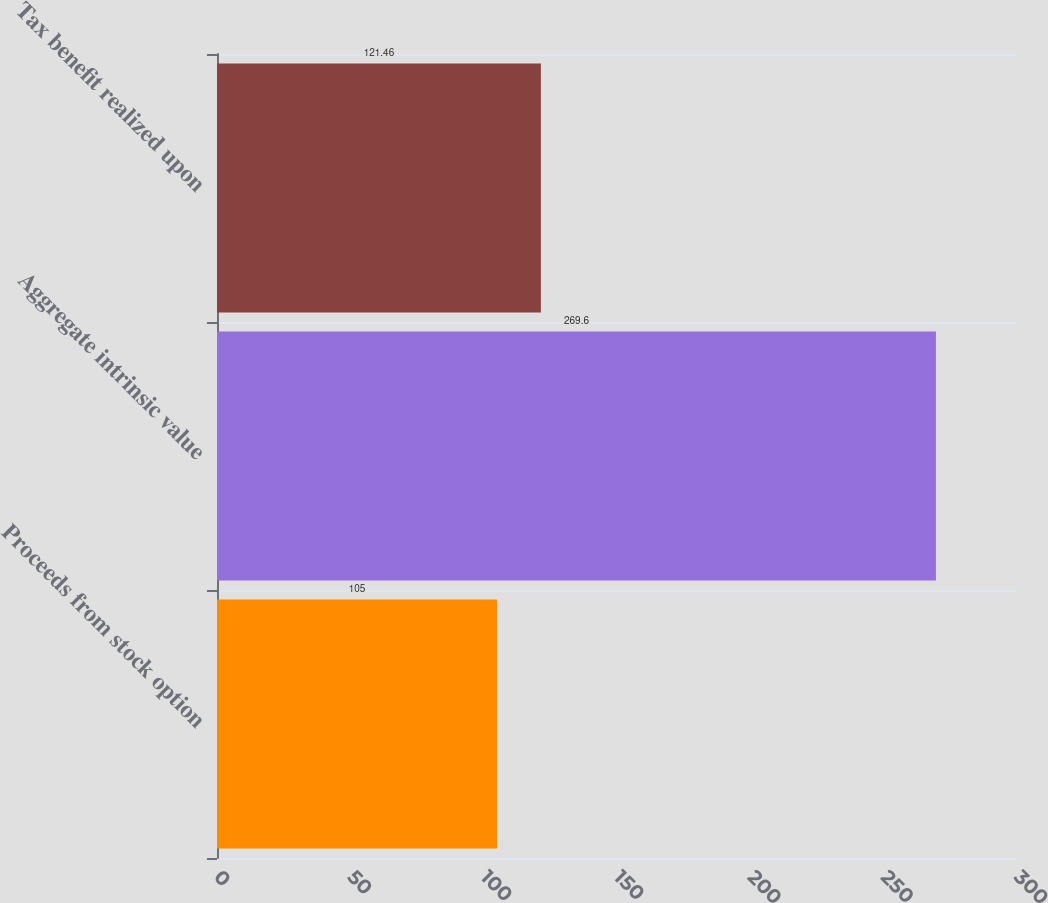<chart> <loc_0><loc_0><loc_500><loc_500><bar_chart><fcel>Proceeds from stock option<fcel>Aggregate intrinsic value<fcel>Tax benefit realized upon<nl><fcel>105<fcel>269.6<fcel>121.46<nl></chart> 